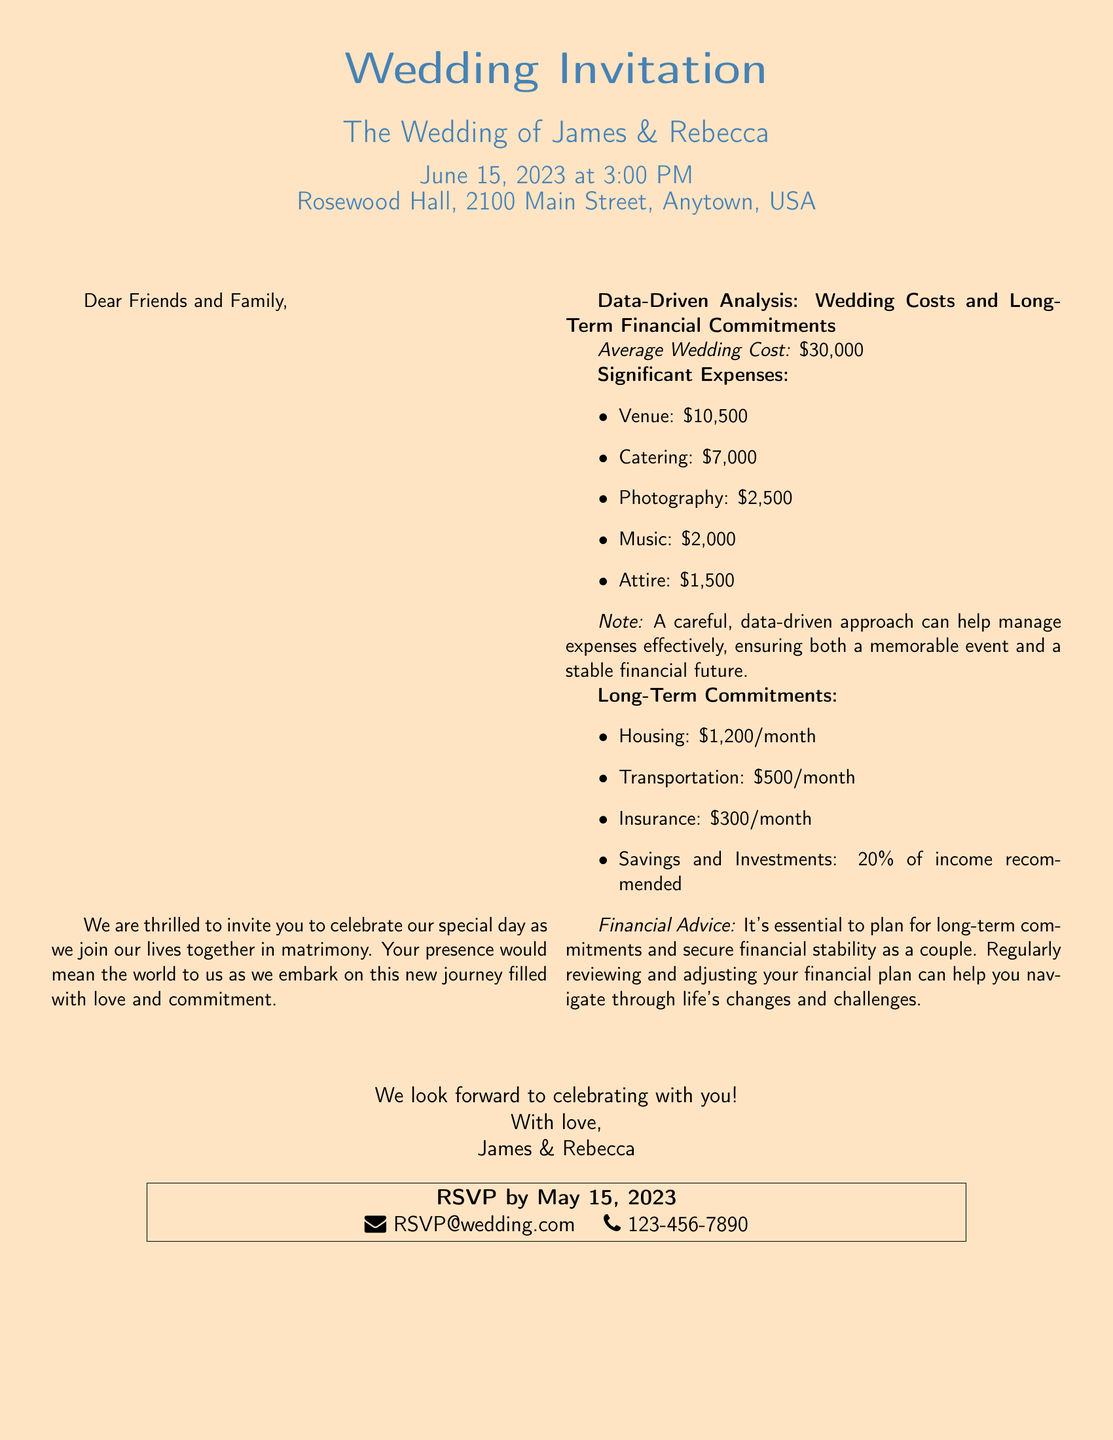What is the name of the couple getting married? The document mentions the couple's names at the top of the invitation, which are James and Rebecca.
Answer: James & Rebecca What is the wedding date? The wedding date is listed in the document under the event details.
Answer: June 15, 2023 What is the venue for the wedding? The venue is stated clearly in the center of the invitation.
Answer: Rosewood Hall, 2100 Main Street, Anytown, USA What is the average wedding cost mentioned? The document specifically states the average wedding cost as part of the data-driven analysis section.
Answer: $30,000 How much is allocated for catering expenses? The detailed significant expenses include the amount for catering, which is specified in the document.
Answer: $7,000 What is the monthly cost for housing? The document provides a breakdown of long-term financial commitments, including housing costs.
Answer: $1,200/month How much should couples save or invest according to the advice? The document suggests a percentage of income for savings and investments, which is part of the financial advice section.
Answer: 20% What is the RSVP deadline? The RSVP deadline is provided at the bottom of the invitation.
Answer: May 15, 2023 What is the contact email for RSVPs? The document includes the RSVP contact information as part of the invitation details.
Answer: RSVP@wedding.com 